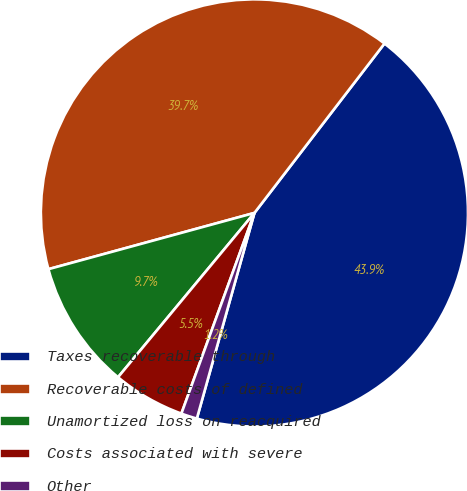<chart> <loc_0><loc_0><loc_500><loc_500><pie_chart><fcel>Taxes recoverable through<fcel>Recoverable costs of defined<fcel>Unamortized loss on reacquired<fcel>Costs associated with severe<fcel>Other<nl><fcel>43.92%<fcel>39.66%<fcel>9.73%<fcel>5.47%<fcel>1.21%<nl></chart> 